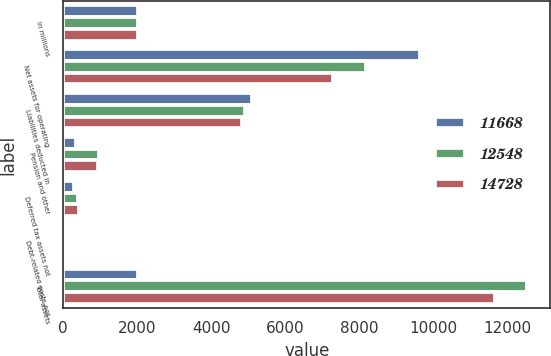Convert chart to OTSL. <chart><loc_0><loc_0><loc_500><loc_500><stacked_bar_chart><ecel><fcel>In millions<fcel>Net assets for operating<fcel>Liabilities deducted in<fcel>Pension and other<fcel>Deferred tax assets not<fcel>Debt-related costs not<fcel>Total assets<nl><fcel>11668<fcel>2013<fcel>9646<fcel>5103<fcel>346<fcel>292<fcel>33<fcel>2011.5<nl><fcel>12548<fcel>2012<fcel>8177<fcel>4913<fcel>977<fcel>410<fcel>25<fcel>12548<nl><fcel>14728<fcel>2011<fcel>7304<fcel>4832<fcel>928<fcel>435<fcel>25<fcel>11668<nl></chart> 